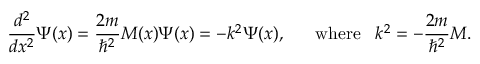<formula> <loc_0><loc_0><loc_500><loc_500>{ \frac { d ^ { 2 } } { d x ^ { 2 } } } \Psi ( x ) = { \frac { 2 m } { \hbar { ^ } { 2 } } } M ( x ) \Psi ( x ) = - k ^ { 2 } \Psi ( x ) , \, w h e r e \, k ^ { 2 } = - { \frac { 2 m } { \hbar { ^ } { 2 } } } M .</formula> 